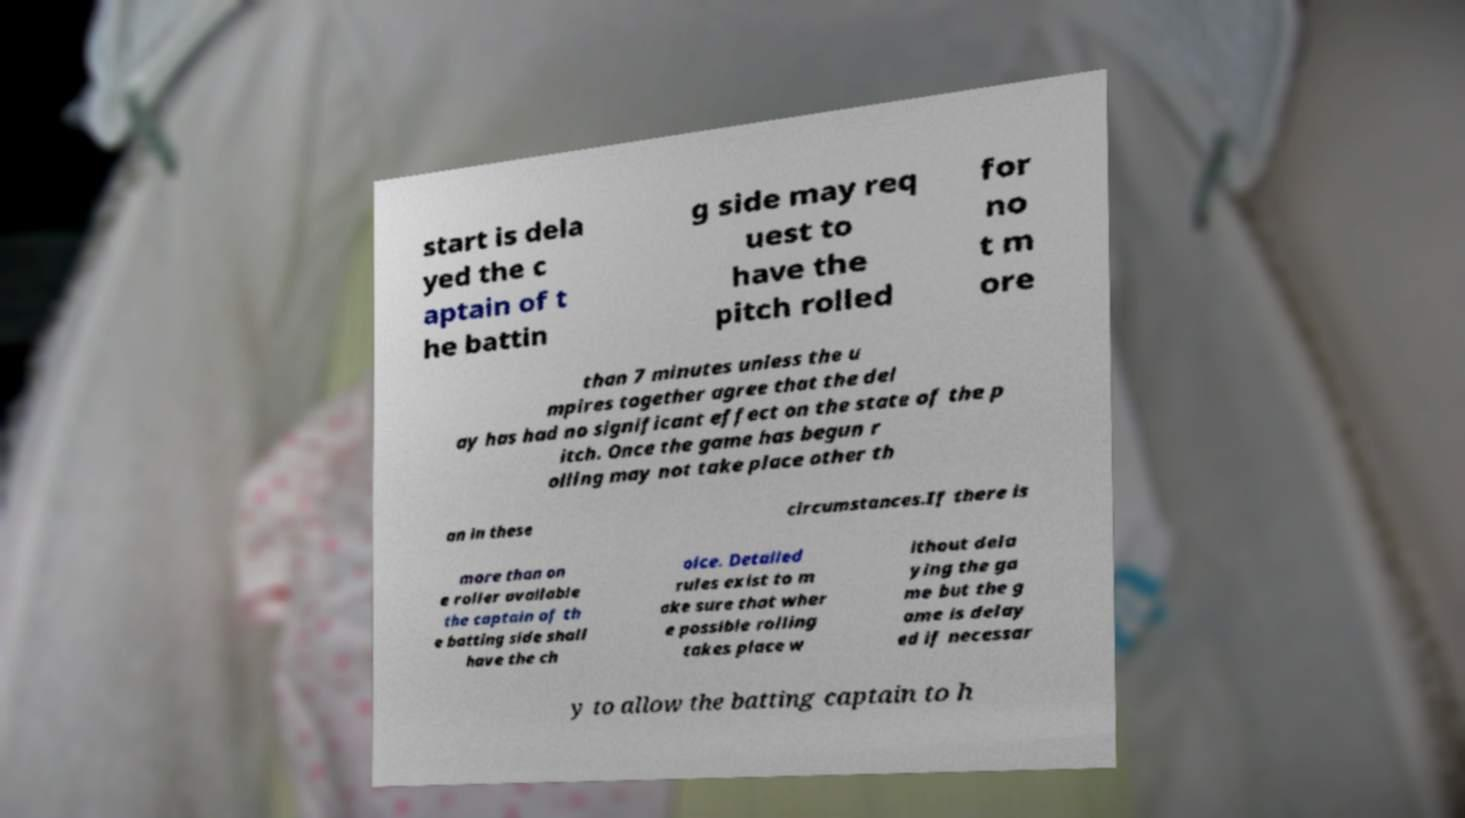Could you extract and type out the text from this image? start is dela yed the c aptain of t he battin g side may req uest to have the pitch rolled for no t m ore than 7 minutes unless the u mpires together agree that the del ay has had no significant effect on the state of the p itch. Once the game has begun r olling may not take place other th an in these circumstances.If there is more than on e roller available the captain of th e batting side shall have the ch oice. Detailed rules exist to m ake sure that wher e possible rolling takes place w ithout dela ying the ga me but the g ame is delay ed if necessar y to allow the batting captain to h 